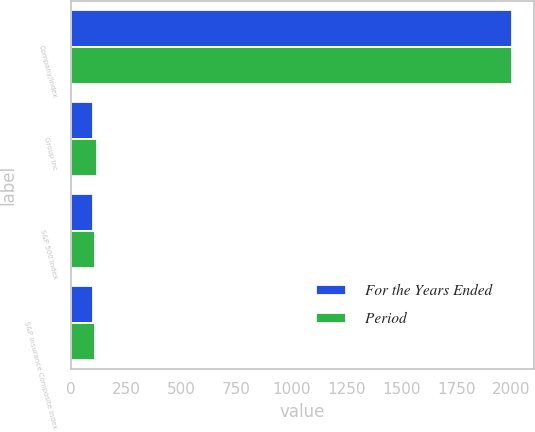<chart> <loc_0><loc_0><loc_500><loc_500><stacked_bar_chart><ecel><fcel>Company/Index<fcel>Group Inc<fcel>S&P 500 Index<fcel>S&P Insurance Composite Index<nl><fcel>For the Years Ended<fcel>2003<fcel>100<fcel>100<fcel>100<nl><fcel>Period<fcel>2004<fcel>119.5<fcel>110.88<fcel>107.25<nl></chart> 